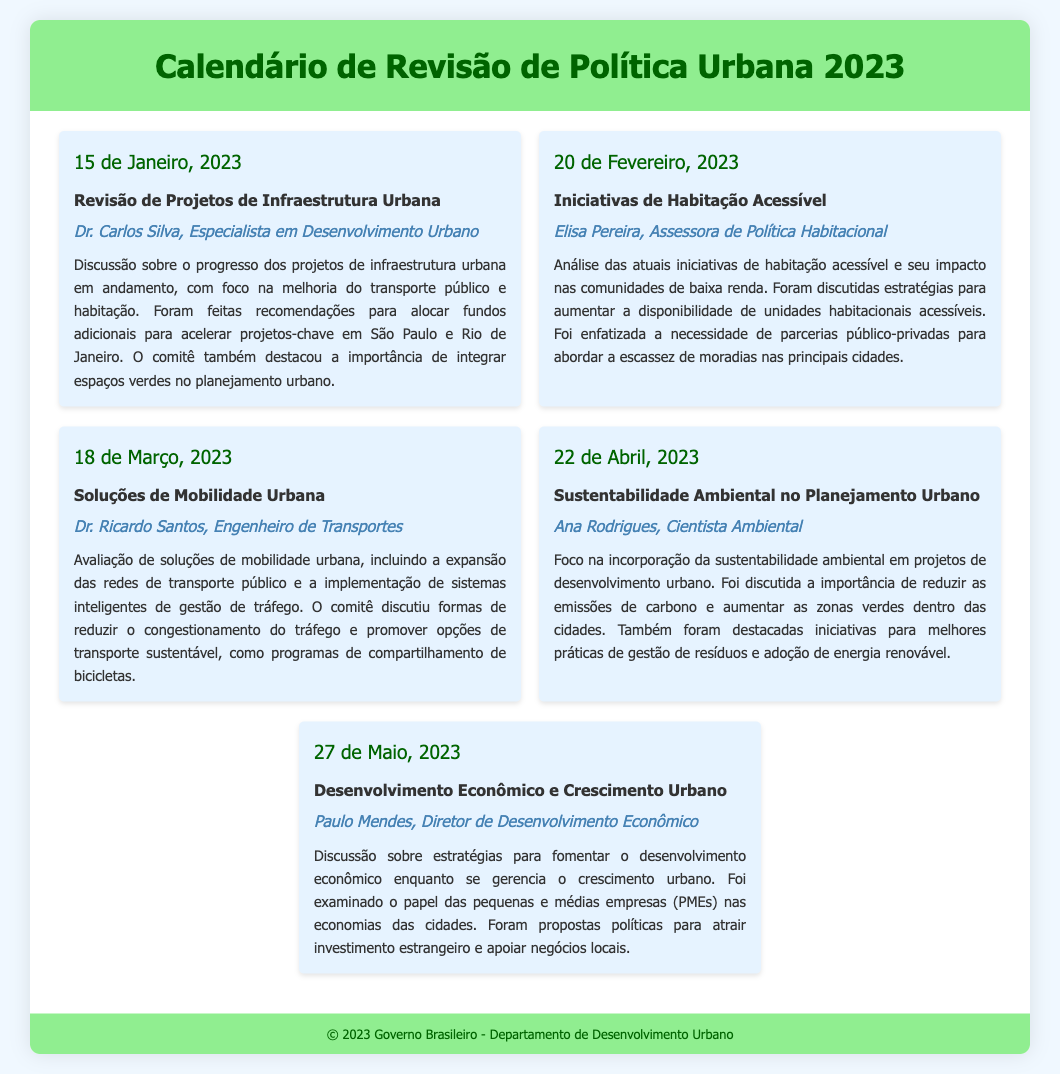What is the date of the first meeting? The first meeting is on January 15, 2023, as noted in the document.
Answer: 15 de Janeiro, 2023 Who is the speaker for the meeting on February 20, 2023? The designated speaker for the February meeting is Elisa Pereira.
Answer: Elisa Pereira What is the agenda for the meeting scheduled on March 18, 2023? The agenda for the March meeting focuses on solutions for urban mobility.
Answer: Soluções de Mobilidade Urbana Which meeting discusses the incorporation of environmental sustainability? The April meeting is focused on sustainability in urban planning.
Answer: 22 de Abril, 2023 How many meetings are scheduled in the document? The document lists five meetings for the year 2023.
Answer: 5 What key issue is addressed in the January meeting? The January meeting addresses urban infrastructure project reviews.
Answer: Revisão de Projetos de Infraestrutura Urbana Who led the discussion on economic development in May? Paulo Mendes is the speaker discussing economic development in May.
Answer: Paulo Mendes What was emphasized during the February meeting regarding housing? The necessity of public-private partnerships in housing was emphasized.
Answer: Parcerias público-privadas What is the main focus of the meeting on April 22, 2023? The main focus is on environmental sustainability in urban planning.
Answer: Sustentabilidade Ambiental no Planejamento Urbano 